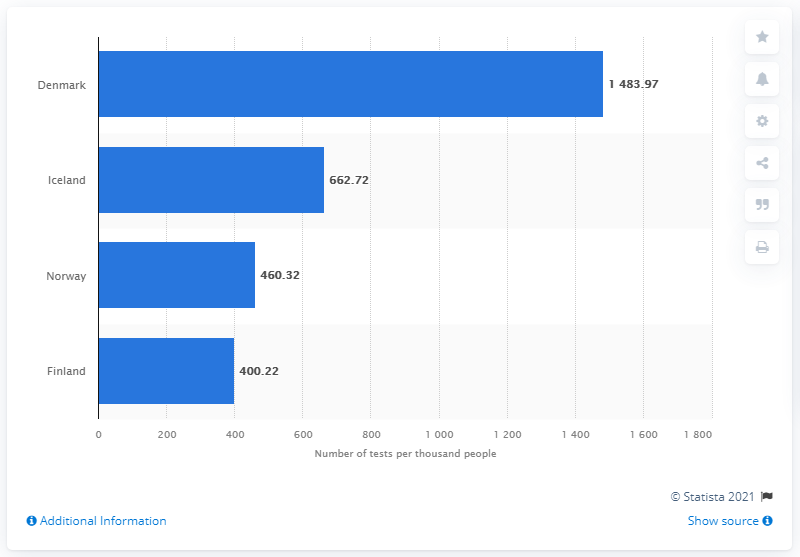Draw attention to some important aspects in this diagram. Denmark had the highest test rate for the coronavirus among all countries. 